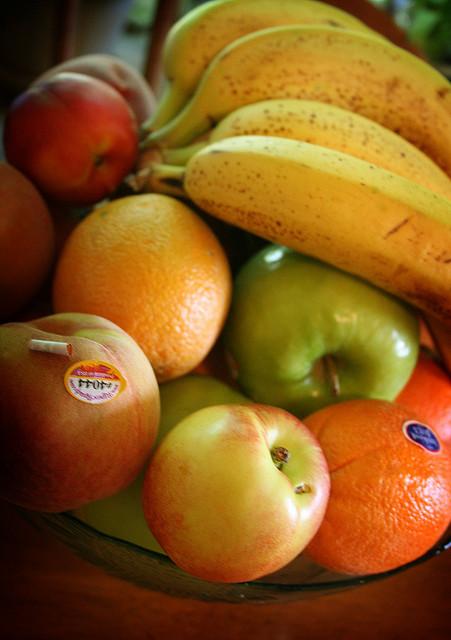How many pieces of fruit has stickers on them?
Give a very brief answer. 2. Are there grapes?
Give a very brief answer. No. What is in the bowl?
Concise answer only. Fruit. 